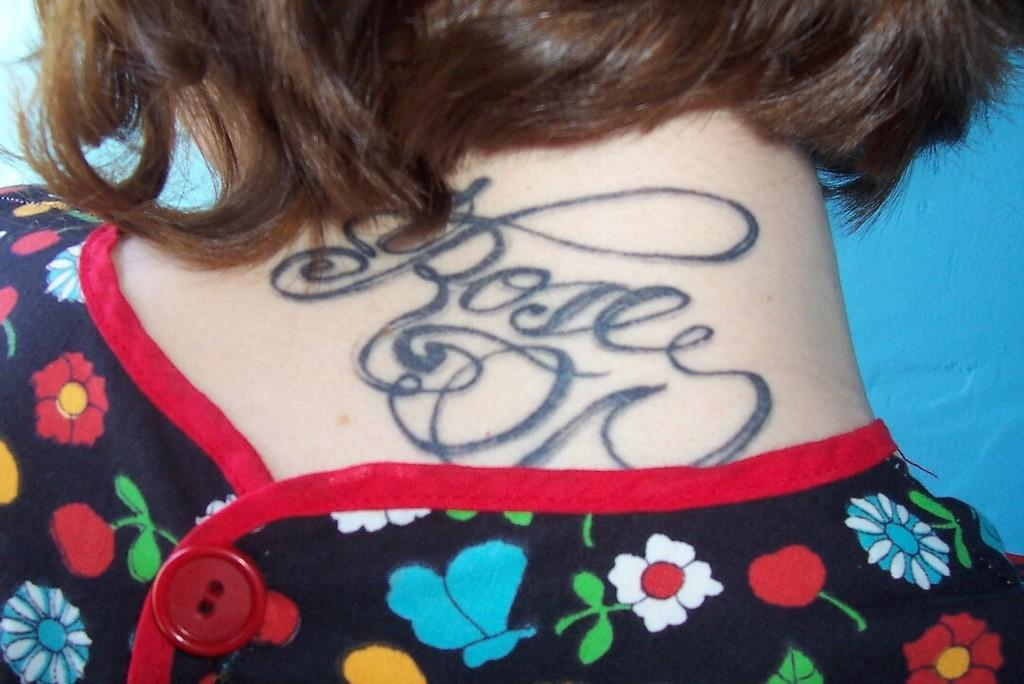What is present on the backside of the neck in the image? There is a tattoo on the backside of the neck in the image. What type of cream is being applied to the field in the image? There is no field or cream present in the image; it only features a tattoo on the backside of the neck. 